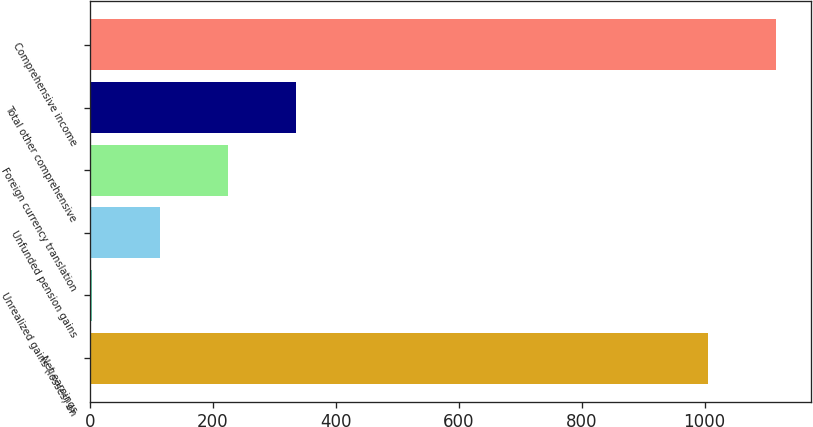Convert chart. <chart><loc_0><loc_0><loc_500><loc_500><bar_chart><fcel>Net earnings<fcel>Unrealized gains (losses) on<fcel>Unfunded pension gains<fcel>Foreign currency translation<fcel>Total other comprehensive<fcel>Comprehensive income<nl><fcel>1006<fcel>4<fcel>114.5<fcel>225<fcel>335.5<fcel>1116.5<nl></chart> 